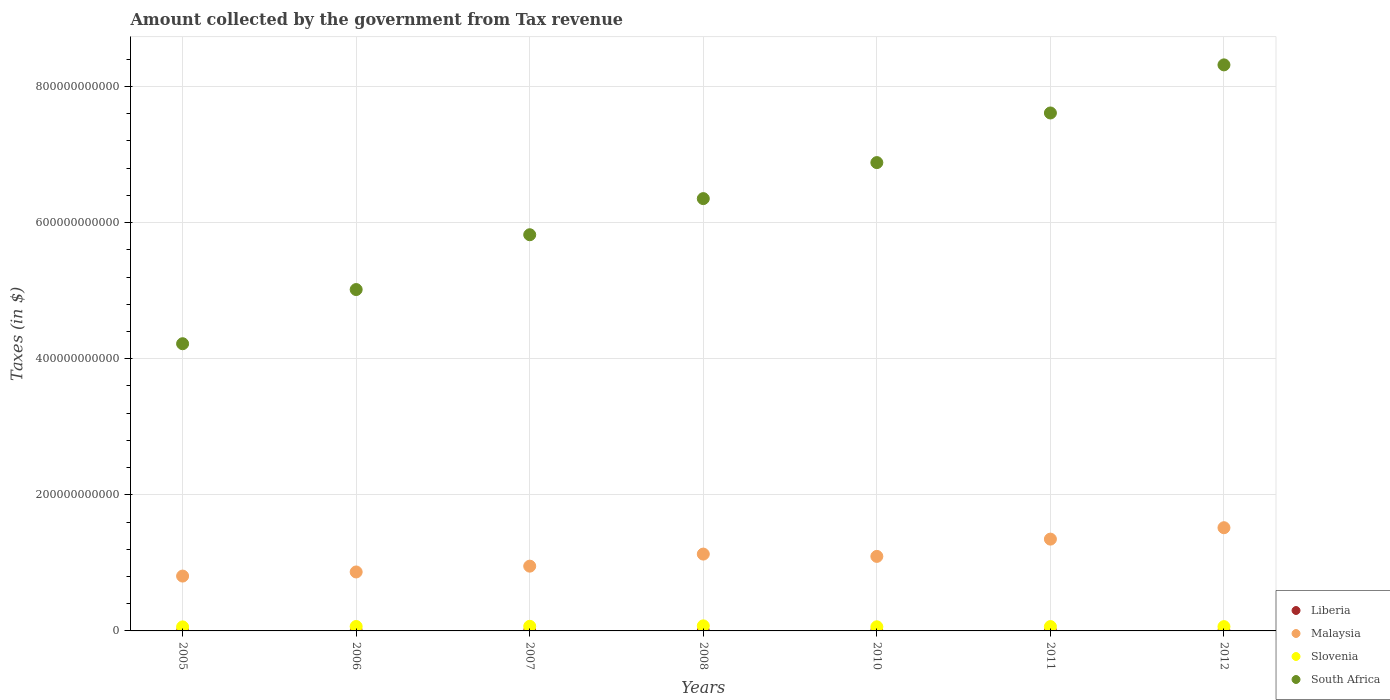How many different coloured dotlines are there?
Make the answer very short. 4. What is the amount collected by the government from tax revenue in Malaysia in 2010?
Give a very brief answer. 1.10e+11. Across all years, what is the maximum amount collected by the government from tax revenue in South Africa?
Make the answer very short. 8.32e+11. Across all years, what is the minimum amount collected by the government from tax revenue in South Africa?
Make the answer very short. 4.22e+11. What is the total amount collected by the government from tax revenue in South Africa in the graph?
Provide a short and direct response. 4.42e+12. What is the difference between the amount collected by the government from tax revenue in Liberia in 2010 and that in 2012?
Provide a short and direct response. -1.79e+06. What is the difference between the amount collected by the government from tax revenue in Slovenia in 2006 and the amount collected by the government from tax revenue in Liberia in 2008?
Your response must be concise. 6.52e+09. What is the average amount collected by the government from tax revenue in Malaysia per year?
Offer a very short reply. 1.10e+11. In the year 2011, what is the difference between the amount collected by the government from tax revenue in Slovenia and amount collected by the government from tax revenue in Malaysia?
Offer a very short reply. -1.28e+11. In how many years, is the amount collected by the government from tax revenue in Malaysia greater than 40000000000 $?
Your response must be concise. 7. What is the ratio of the amount collected by the government from tax revenue in Liberia in 2006 to that in 2011?
Provide a short and direct response. 0.38. Is the difference between the amount collected by the government from tax revenue in Slovenia in 2007 and 2012 greater than the difference between the amount collected by the government from tax revenue in Malaysia in 2007 and 2012?
Offer a very short reply. Yes. What is the difference between the highest and the second highest amount collected by the government from tax revenue in South Africa?
Ensure brevity in your answer.  7.07e+1. What is the difference between the highest and the lowest amount collected by the government from tax revenue in South Africa?
Offer a very short reply. 4.10e+11. In how many years, is the amount collected by the government from tax revenue in Malaysia greater than the average amount collected by the government from tax revenue in Malaysia taken over all years?
Offer a very short reply. 3. Is it the case that in every year, the sum of the amount collected by the government from tax revenue in Slovenia and amount collected by the government from tax revenue in Liberia  is greater than the sum of amount collected by the government from tax revenue in South Africa and amount collected by the government from tax revenue in Malaysia?
Ensure brevity in your answer.  No. Is it the case that in every year, the sum of the amount collected by the government from tax revenue in Slovenia and amount collected by the government from tax revenue in Liberia  is greater than the amount collected by the government from tax revenue in Malaysia?
Offer a very short reply. No. Does the amount collected by the government from tax revenue in Malaysia monotonically increase over the years?
Your answer should be very brief. No. Is the amount collected by the government from tax revenue in Malaysia strictly greater than the amount collected by the government from tax revenue in South Africa over the years?
Your answer should be compact. No. Is the amount collected by the government from tax revenue in Slovenia strictly less than the amount collected by the government from tax revenue in Malaysia over the years?
Your response must be concise. Yes. How many dotlines are there?
Offer a terse response. 4. How many years are there in the graph?
Keep it short and to the point. 7. What is the difference between two consecutive major ticks on the Y-axis?
Your answer should be very brief. 2.00e+11. Are the values on the major ticks of Y-axis written in scientific E-notation?
Your answer should be very brief. No. Does the graph contain grids?
Keep it short and to the point. Yes. How are the legend labels stacked?
Your response must be concise. Vertical. What is the title of the graph?
Give a very brief answer. Amount collected by the government from Tax revenue. Does "Seychelles" appear as one of the legend labels in the graph?
Keep it short and to the point. No. What is the label or title of the X-axis?
Provide a short and direct response. Years. What is the label or title of the Y-axis?
Make the answer very short. Taxes (in $). What is the Taxes (in $) in Liberia in 2005?
Provide a succinct answer. 1.27e+06. What is the Taxes (in $) of Malaysia in 2005?
Your response must be concise. 8.06e+1. What is the Taxes (in $) of Slovenia in 2005?
Offer a very short reply. 5.90e+09. What is the Taxes (in $) in South Africa in 2005?
Keep it short and to the point. 4.22e+11. What is the Taxes (in $) of Liberia in 2006?
Your response must be concise. 1.40e+06. What is the Taxes (in $) of Malaysia in 2006?
Your response must be concise. 8.66e+1. What is the Taxes (in $) in Slovenia in 2006?
Offer a terse response. 6.52e+09. What is the Taxes (in $) in South Africa in 2006?
Ensure brevity in your answer.  5.02e+11. What is the Taxes (in $) of Liberia in 2007?
Your answer should be compact. 2.29e+06. What is the Taxes (in $) of Malaysia in 2007?
Your answer should be compact. 9.52e+1. What is the Taxes (in $) of Slovenia in 2007?
Give a very brief answer. 6.79e+09. What is the Taxes (in $) of South Africa in 2007?
Make the answer very short. 5.82e+11. What is the Taxes (in $) in Liberia in 2008?
Your answer should be very brief. 2.69e+06. What is the Taxes (in $) of Malaysia in 2008?
Provide a succinct answer. 1.13e+11. What is the Taxes (in $) in Slovenia in 2008?
Offer a very short reply. 7.43e+09. What is the Taxes (in $) of South Africa in 2008?
Offer a very short reply. 6.35e+11. What is the Taxes (in $) in Liberia in 2010?
Keep it short and to the point. 3.14e+06. What is the Taxes (in $) of Malaysia in 2010?
Offer a very short reply. 1.10e+11. What is the Taxes (in $) in Slovenia in 2010?
Provide a succinct answer. 6.07e+09. What is the Taxes (in $) in South Africa in 2010?
Provide a succinct answer. 6.88e+11. What is the Taxes (in $) in Liberia in 2011?
Your response must be concise. 3.70e+06. What is the Taxes (in $) of Malaysia in 2011?
Your answer should be very brief. 1.35e+11. What is the Taxes (in $) in Slovenia in 2011?
Give a very brief answer. 6.39e+09. What is the Taxes (in $) in South Africa in 2011?
Offer a very short reply. 7.61e+11. What is the Taxes (in $) in Liberia in 2012?
Your answer should be compact. 4.93e+06. What is the Taxes (in $) of Malaysia in 2012?
Ensure brevity in your answer.  1.52e+11. What is the Taxes (in $) of Slovenia in 2012?
Make the answer very short. 6.32e+09. What is the Taxes (in $) of South Africa in 2012?
Your answer should be compact. 8.32e+11. Across all years, what is the maximum Taxes (in $) of Liberia?
Provide a short and direct response. 4.93e+06. Across all years, what is the maximum Taxes (in $) of Malaysia?
Give a very brief answer. 1.52e+11. Across all years, what is the maximum Taxes (in $) of Slovenia?
Offer a very short reply. 7.43e+09. Across all years, what is the maximum Taxes (in $) in South Africa?
Make the answer very short. 8.32e+11. Across all years, what is the minimum Taxes (in $) of Liberia?
Keep it short and to the point. 1.27e+06. Across all years, what is the minimum Taxes (in $) in Malaysia?
Your response must be concise. 8.06e+1. Across all years, what is the minimum Taxes (in $) of Slovenia?
Make the answer very short. 5.90e+09. Across all years, what is the minimum Taxes (in $) of South Africa?
Offer a terse response. 4.22e+11. What is the total Taxes (in $) in Liberia in the graph?
Your answer should be very brief. 1.94e+07. What is the total Taxes (in $) of Malaysia in the graph?
Keep it short and to the point. 7.71e+11. What is the total Taxes (in $) in Slovenia in the graph?
Ensure brevity in your answer.  4.54e+1. What is the total Taxes (in $) in South Africa in the graph?
Your answer should be compact. 4.42e+12. What is the difference between the Taxes (in $) in Liberia in 2005 and that in 2006?
Your answer should be very brief. -1.25e+05. What is the difference between the Taxes (in $) in Malaysia in 2005 and that in 2006?
Your answer should be very brief. -6.04e+09. What is the difference between the Taxes (in $) in Slovenia in 2005 and that in 2006?
Make the answer very short. -6.18e+08. What is the difference between the Taxes (in $) in South Africa in 2005 and that in 2006?
Offer a very short reply. -7.96e+1. What is the difference between the Taxes (in $) in Liberia in 2005 and that in 2007?
Offer a terse response. -1.02e+06. What is the difference between the Taxes (in $) of Malaysia in 2005 and that in 2007?
Ensure brevity in your answer.  -1.46e+1. What is the difference between the Taxes (in $) of Slovenia in 2005 and that in 2007?
Provide a succinct answer. -8.91e+08. What is the difference between the Taxes (in $) in South Africa in 2005 and that in 2007?
Your answer should be compact. -1.60e+11. What is the difference between the Taxes (in $) in Liberia in 2005 and that in 2008?
Offer a very short reply. -1.42e+06. What is the difference between the Taxes (in $) of Malaysia in 2005 and that in 2008?
Make the answer very short. -3.23e+1. What is the difference between the Taxes (in $) in Slovenia in 2005 and that in 2008?
Your answer should be compact. -1.53e+09. What is the difference between the Taxes (in $) of South Africa in 2005 and that in 2008?
Your answer should be compact. -2.13e+11. What is the difference between the Taxes (in $) of Liberia in 2005 and that in 2010?
Ensure brevity in your answer.  -1.87e+06. What is the difference between the Taxes (in $) of Malaysia in 2005 and that in 2010?
Offer a terse response. -2.89e+1. What is the difference between the Taxes (in $) in Slovenia in 2005 and that in 2010?
Your answer should be compact. -1.66e+08. What is the difference between the Taxes (in $) of South Africa in 2005 and that in 2010?
Provide a short and direct response. -2.66e+11. What is the difference between the Taxes (in $) in Liberia in 2005 and that in 2011?
Ensure brevity in your answer.  -2.43e+06. What is the difference between the Taxes (in $) of Malaysia in 2005 and that in 2011?
Offer a very short reply. -5.43e+1. What is the difference between the Taxes (in $) in Slovenia in 2005 and that in 2011?
Keep it short and to the point. -4.91e+08. What is the difference between the Taxes (in $) in South Africa in 2005 and that in 2011?
Provide a succinct answer. -3.39e+11. What is the difference between the Taxes (in $) in Liberia in 2005 and that in 2012?
Ensure brevity in your answer.  -3.66e+06. What is the difference between the Taxes (in $) in Malaysia in 2005 and that in 2012?
Make the answer very short. -7.10e+1. What is the difference between the Taxes (in $) of Slovenia in 2005 and that in 2012?
Keep it short and to the point. -4.16e+08. What is the difference between the Taxes (in $) of South Africa in 2005 and that in 2012?
Your answer should be very brief. -4.10e+11. What is the difference between the Taxes (in $) in Liberia in 2006 and that in 2007?
Offer a terse response. -8.90e+05. What is the difference between the Taxes (in $) in Malaysia in 2006 and that in 2007?
Ensure brevity in your answer.  -8.54e+09. What is the difference between the Taxes (in $) in Slovenia in 2006 and that in 2007?
Your answer should be very brief. -2.73e+08. What is the difference between the Taxes (in $) in South Africa in 2006 and that in 2007?
Your answer should be very brief. -8.05e+1. What is the difference between the Taxes (in $) in Liberia in 2006 and that in 2008?
Keep it short and to the point. -1.29e+06. What is the difference between the Taxes (in $) of Malaysia in 2006 and that in 2008?
Offer a terse response. -2.63e+1. What is the difference between the Taxes (in $) in Slovenia in 2006 and that in 2008?
Ensure brevity in your answer.  -9.12e+08. What is the difference between the Taxes (in $) of South Africa in 2006 and that in 2008?
Offer a very short reply. -1.34e+11. What is the difference between the Taxes (in $) in Liberia in 2006 and that in 2010?
Ensure brevity in your answer.  -1.74e+06. What is the difference between the Taxes (in $) of Malaysia in 2006 and that in 2010?
Provide a succinct answer. -2.29e+1. What is the difference between the Taxes (in $) in Slovenia in 2006 and that in 2010?
Keep it short and to the point. 4.52e+08. What is the difference between the Taxes (in $) in South Africa in 2006 and that in 2010?
Your response must be concise. -1.87e+11. What is the difference between the Taxes (in $) in Liberia in 2006 and that in 2011?
Your answer should be compact. -2.31e+06. What is the difference between the Taxes (in $) of Malaysia in 2006 and that in 2011?
Make the answer very short. -4.83e+1. What is the difference between the Taxes (in $) in Slovenia in 2006 and that in 2011?
Make the answer very short. 1.27e+08. What is the difference between the Taxes (in $) in South Africa in 2006 and that in 2011?
Your response must be concise. -2.59e+11. What is the difference between the Taxes (in $) in Liberia in 2006 and that in 2012?
Your response must be concise. -3.53e+06. What is the difference between the Taxes (in $) of Malaysia in 2006 and that in 2012?
Offer a terse response. -6.50e+1. What is the difference between the Taxes (in $) of Slovenia in 2006 and that in 2012?
Your response must be concise. 2.02e+08. What is the difference between the Taxes (in $) of South Africa in 2006 and that in 2012?
Provide a succinct answer. -3.30e+11. What is the difference between the Taxes (in $) in Liberia in 2007 and that in 2008?
Provide a short and direct response. -4.02e+05. What is the difference between the Taxes (in $) in Malaysia in 2007 and that in 2008?
Ensure brevity in your answer.  -1.77e+1. What is the difference between the Taxes (in $) of Slovenia in 2007 and that in 2008?
Keep it short and to the point. -6.39e+08. What is the difference between the Taxes (in $) of South Africa in 2007 and that in 2008?
Your answer should be compact. -5.31e+1. What is the difference between the Taxes (in $) of Liberia in 2007 and that in 2010?
Ensure brevity in your answer.  -8.50e+05. What is the difference between the Taxes (in $) of Malaysia in 2007 and that in 2010?
Offer a very short reply. -1.43e+1. What is the difference between the Taxes (in $) in Slovenia in 2007 and that in 2010?
Keep it short and to the point. 7.25e+08. What is the difference between the Taxes (in $) in South Africa in 2007 and that in 2010?
Give a very brief answer. -1.06e+11. What is the difference between the Taxes (in $) of Liberia in 2007 and that in 2011?
Offer a very short reply. -1.42e+06. What is the difference between the Taxes (in $) of Malaysia in 2007 and that in 2011?
Give a very brief answer. -3.97e+1. What is the difference between the Taxes (in $) in Slovenia in 2007 and that in 2011?
Make the answer very short. 4.00e+08. What is the difference between the Taxes (in $) of South Africa in 2007 and that in 2011?
Make the answer very short. -1.79e+11. What is the difference between the Taxes (in $) in Liberia in 2007 and that in 2012?
Provide a short and direct response. -2.64e+06. What is the difference between the Taxes (in $) of Malaysia in 2007 and that in 2012?
Make the answer very short. -5.65e+1. What is the difference between the Taxes (in $) in Slovenia in 2007 and that in 2012?
Your answer should be very brief. 4.75e+08. What is the difference between the Taxes (in $) of South Africa in 2007 and that in 2012?
Your answer should be compact. -2.50e+11. What is the difference between the Taxes (in $) of Liberia in 2008 and that in 2010?
Offer a terse response. -4.48e+05. What is the difference between the Taxes (in $) of Malaysia in 2008 and that in 2010?
Make the answer very short. 3.38e+09. What is the difference between the Taxes (in $) in Slovenia in 2008 and that in 2010?
Provide a succinct answer. 1.36e+09. What is the difference between the Taxes (in $) in South Africa in 2008 and that in 2010?
Your answer should be compact. -5.29e+1. What is the difference between the Taxes (in $) of Liberia in 2008 and that in 2011?
Offer a terse response. -1.01e+06. What is the difference between the Taxes (in $) in Malaysia in 2008 and that in 2011?
Give a very brief answer. -2.20e+1. What is the difference between the Taxes (in $) of Slovenia in 2008 and that in 2011?
Your response must be concise. 1.04e+09. What is the difference between the Taxes (in $) of South Africa in 2008 and that in 2011?
Your answer should be very brief. -1.26e+11. What is the difference between the Taxes (in $) of Liberia in 2008 and that in 2012?
Your answer should be very brief. -2.24e+06. What is the difference between the Taxes (in $) in Malaysia in 2008 and that in 2012?
Your answer should be very brief. -3.87e+1. What is the difference between the Taxes (in $) of Slovenia in 2008 and that in 2012?
Ensure brevity in your answer.  1.11e+09. What is the difference between the Taxes (in $) of South Africa in 2008 and that in 2012?
Offer a very short reply. -1.97e+11. What is the difference between the Taxes (in $) of Liberia in 2010 and that in 2011?
Provide a succinct answer. -5.66e+05. What is the difference between the Taxes (in $) in Malaysia in 2010 and that in 2011?
Provide a short and direct response. -2.54e+1. What is the difference between the Taxes (in $) of Slovenia in 2010 and that in 2011?
Make the answer very short. -3.25e+08. What is the difference between the Taxes (in $) of South Africa in 2010 and that in 2011?
Make the answer very short. -7.29e+1. What is the difference between the Taxes (in $) of Liberia in 2010 and that in 2012?
Provide a short and direct response. -1.79e+06. What is the difference between the Taxes (in $) in Malaysia in 2010 and that in 2012?
Offer a very short reply. -4.21e+1. What is the difference between the Taxes (in $) of Slovenia in 2010 and that in 2012?
Provide a succinct answer. -2.50e+08. What is the difference between the Taxes (in $) in South Africa in 2010 and that in 2012?
Offer a terse response. -1.44e+11. What is the difference between the Taxes (in $) in Liberia in 2011 and that in 2012?
Offer a very short reply. -1.22e+06. What is the difference between the Taxes (in $) of Malaysia in 2011 and that in 2012?
Your response must be concise. -1.68e+1. What is the difference between the Taxes (in $) in Slovenia in 2011 and that in 2012?
Your answer should be compact. 7.47e+07. What is the difference between the Taxes (in $) in South Africa in 2011 and that in 2012?
Give a very brief answer. -7.07e+1. What is the difference between the Taxes (in $) in Liberia in 2005 and the Taxes (in $) in Malaysia in 2006?
Provide a succinct answer. -8.66e+1. What is the difference between the Taxes (in $) of Liberia in 2005 and the Taxes (in $) of Slovenia in 2006?
Provide a succinct answer. -6.52e+09. What is the difference between the Taxes (in $) of Liberia in 2005 and the Taxes (in $) of South Africa in 2006?
Provide a short and direct response. -5.02e+11. What is the difference between the Taxes (in $) of Malaysia in 2005 and the Taxes (in $) of Slovenia in 2006?
Offer a terse response. 7.41e+1. What is the difference between the Taxes (in $) of Malaysia in 2005 and the Taxes (in $) of South Africa in 2006?
Make the answer very short. -4.21e+11. What is the difference between the Taxes (in $) in Slovenia in 2005 and the Taxes (in $) in South Africa in 2006?
Ensure brevity in your answer.  -4.96e+11. What is the difference between the Taxes (in $) in Liberia in 2005 and the Taxes (in $) in Malaysia in 2007?
Your answer should be very brief. -9.52e+1. What is the difference between the Taxes (in $) in Liberia in 2005 and the Taxes (in $) in Slovenia in 2007?
Provide a short and direct response. -6.79e+09. What is the difference between the Taxes (in $) in Liberia in 2005 and the Taxes (in $) in South Africa in 2007?
Your answer should be very brief. -5.82e+11. What is the difference between the Taxes (in $) in Malaysia in 2005 and the Taxes (in $) in Slovenia in 2007?
Offer a terse response. 7.38e+1. What is the difference between the Taxes (in $) in Malaysia in 2005 and the Taxes (in $) in South Africa in 2007?
Keep it short and to the point. -5.02e+11. What is the difference between the Taxes (in $) in Slovenia in 2005 and the Taxes (in $) in South Africa in 2007?
Offer a very short reply. -5.76e+11. What is the difference between the Taxes (in $) in Liberia in 2005 and the Taxes (in $) in Malaysia in 2008?
Make the answer very short. -1.13e+11. What is the difference between the Taxes (in $) in Liberia in 2005 and the Taxes (in $) in Slovenia in 2008?
Provide a short and direct response. -7.43e+09. What is the difference between the Taxes (in $) in Liberia in 2005 and the Taxes (in $) in South Africa in 2008?
Ensure brevity in your answer.  -6.35e+11. What is the difference between the Taxes (in $) of Malaysia in 2005 and the Taxes (in $) of Slovenia in 2008?
Provide a succinct answer. 7.32e+1. What is the difference between the Taxes (in $) in Malaysia in 2005 and the Taxes (in $) in South Africa in 2008?
Your answer should be compact. -5.55e+11. What is the difference between the Taxes (in $) in Slovenia in 2005 and the Taxes (in $) in South Africa in 2008?
Your answer should be compact. -6.29e+11. What is the difference between the Taxes (in $) of Liberia in 2005 and the Taxes (in $) of Malaysia in 2010?
Provide a short and direct response. -1.10e+11. What is the difference between the Taxes (in $) of Liberia in 2005 and the Taxes (in $) of Slovenia in 2010?
Make the answer very short. -6.06e+09. What is the difference between the Taxes (in $) of Liberia in 2005 and the Taxes (in $) of South Africa in 2010?
Provide a succinct answer. -6.88e+11. What is the difference between the Taxes (in $) of Malaysia in 2005 and the Taxes (in $) of Slovenia in 2010?
Your answer should be compact. 7.45e+1. What is the difference between the Taxes (in $) of Malaysia in 2005 and the Taxes (in $) of South Africa in 2010?
Provide a short and direct response. -6.08e+11. What is the difference between the Taxes (in $) in Slovenia in 2005 and the Taxes (in $) in South Africa in 2010?
Your answer should be compact. -6.82e+11. What is the difference between the Taxes (in $) of Liberia in 2005 and the Taxes (in $) of Malaysia in 2011?
Offer a terse response. -1.35e+11. What is the difference between the Taxes (in $) of Liberia in 2005 and the Taxes (in $) of Slovenia in 2011?
Your response must be concise. -6.39e+09. What is the difference between the Taxes (in $) of Liberia in 2005 and the Taxes (in $) of South Africa in 2011?
Your answer should be very brief. -7.61e+11. What is the difference between the Taxes (in $) of Malaysia in 2005 and the Taxes (in $) of Slovenia in 2011?
Give a very brief answer. 7.42e+1. What is the difference between the Taxes (in $) of Malaysia in 2005 and the Taxes (in $) of South Africa in 2011?
Give a very brief answer. -6.80e+11. What is the difference between the Taxes (in $) in Slovenia in 2005 and the Taxes (in $) in South Africa in 2011?
Your answer should be very brief. -7.55e+11. What is the difference between the Taxes (in $) of Liberia in 2005 and the Taxes (in $) of Malaysia in 2012?
Ensure brevity in your answer.  -1.52e+11. What is the difference between the Taxes (in $) of Liberia in 2005 and the Taxes (in $) of Slovenia in 2012?
Keep it short and to the point. -6.31e+09. What is the difference between the Taxes (in $) in Liberia in 2005 and the Taxes (in $) in South Africa in 2012?
Give a very brief answer. -8.32e+11. What is the difference between the Taxes (in $) of Malaysia in 2005 and the Taxes (in $) of Slovenia in 2012?
Your answer should be compact. 7.43e+1. What is the difference between the Taxes (in $) of Malaysia in 2005 and the Taxes (in $) of South Africa in 2012?
Give a very brief answer. -7.51e+11. What is the difference between the Taxes (in $) of Slovenia in 2005 and the Taxes (in $) of South Africa in 2012?
Offer a terse response. -8.26e+11. What is the difference between the Taxes (in $) in Liberia in 2006 and the Taxes (in $) in Malaysia in 2007?
Your answer should be compact. -9.52e+1. What is the difference between the Taxes (in $) in Liberia in 2006 and the Taxes (in $) in Slovenia in 2007?
Keep it short and to the point. -6.79e+09. What is the difference between the Taxes (in $) in Liberia in 2006 and the Taxes (in $) in South Africa in 2007?
Offer a very short reply. -5.82e+11. What is the difference between the Taxes (in $) of Malaysia in 2006 and the Taxes (in $) of Slovenia in 2007?
Offer a very short reply. 7.98e+1. What is the difference between the Taxes (in $) of Malaysia in 2006 and the Taxes (in $) of South Africa in 2007?
Offer a terse response. -4.96e+11. What is the difference between the Taxes (in $) of Slovenia in 2006 and the Taxes (in $) of South Africa in 2007?
Your response must be concise. -5.76e+11. What is the difference between the Taxes (in $) in Liberia in 2006 and the Taxes (in $) in Malaysia in 2008?
Offer a terse response. -1.13e+11. What is the difference between the Taxes (in $) of Liberia in 2006 and the Taxes (in $) of Slovenia in 2008?
Ensure brevity in your answer.  -7.43e+09. What is the difference between the Taxes (in $) in Liberia in 2006 and the Taxes (in $) in South Africa in 2008?
Keep it short and to the point. -6.35e+11. What is the difference between the Taxes (in $) of Malaysia in 2006 and the Taxes (in $) of Slovenia in 2008?
Keep it short and to the point. 7.92e+1. What is the difference between the Taxes (in $) in Malaysia in 2006 and the Taxes (in $) in South Africa in 2008?
Provide a short and direct response. -5.49e+11. What is the difference between the Taxes (in $) of Slovenia in 2006 and the Taxes (in $) of South Africa in 2008?
Your response must be concise. -6.29e+11. What is the difference between the Taxes (in $) in Liberia in 2006 and the Taxes (in $) in Malaysia in 2010?
Your response must be concise. -1.10e+11. What is the difference between the Taxes (in $) of Liberia in 2006 and the Taxes (in $) of Slovenia in 2010?
Make the answer very short. -6.06e+09. What is the difference between the Taxes (in $) in Liberia in 2006 and the Taxes (in $) in South Africa in 2010?
Provide a succinct answer. -6.88e+11. What is the difference between the Taxes (in $) of Malaysia in 2006 and the Taxes (in $) of Slovenia in 2010?
Ensure brevity in your answer.  8.06e+1. What is the difference between the Taxes (in $) in Malaysia in 2006 and the Taxes (in $) in South Africa in 2010?
Give a very brief answer. -6.02e+11. What is the difference between the Taxes (in $) in Slovenia in 2006 and the Taxes (in $) in South Africa in 2010?
Make the answer very short. -6.82e+11. What is the difference between the Taxes (in $) of Liberia in 2006 and the Taxes (in $) of Malaysia in 2011?
Provide a succinct answer. -1.35e+11. What is the difference between the Taxes (in $) in Liberia in 2006 and the Taxes (in $) in Slovenia in 2011?
Make the answer very short. -6.39e+09. What is the difference between the Taxes (in $) of Liberia in 2006 and the Taxes (in $) of South Africa in 2011?
Keep it short and to the point. -7.61e+11. What is the difference between the Taxes (in $) of Malaysia in 2006 and the Taxes (in $) of Slovenia in 2011?
Provide a succinct answer. 8.02e+1. What is the difference between the Taxes (in $) in Malaysia in 2006 and the Taxes (in $) in South Africa in 2011?
Your answer should be very brief. -6.74e+11. What is the difference between the Taxes (in $) of Slovenia in 2006 and the Taxes (in $) of South Africa in 2011?
Provide a short and direct response. -7.55e+11. What is the difference between the Taxes (in $) in Liberia in 2006 and the Taxes (in $) in Malaysia in 2012?
Your answer should be very brief. -1.52e+11. What is the difference between the Taxes (in $) in Liberia in 2006 and the Taxes (in $) in Slovenia in 2012?
Provide a short and direct response. -6.31e+09. What is the difference between the Taxes (in $) of Liberia in 2006 and the Taxes (in $) of South Africa in 2012?
Provide a short and direct response. -8.32e+11. What is the difference between the Taxes (in $) in Malaysia in 2006 and the Taxes (in $) in Slovenia in 2012?
Keep it short and to the point. 8.03e+1. What is the difference between the Taxes (in $) in Malaysia in 2006 and the Taxes (in $) in South Africa in 2012?
Offer a very short reply. -7.45e+11. What is the difference between the Taxes (in $) in Slovenia in 2006 and the Taxes (in $) in South Africa in 2012?
Your answer should be compact. -8.25e+11. What is the difference between the Taxes (in $) in Liberia in 2007 and the Taxes (in $) in Malaysia in 2008?
Give a very brief answer. -1.13e+11. What is the difference between the Taxes (in $) of Liberia in 2007 and the Taxes (in $) of Slovenia in 2008?
Give a very brief answer. -7.43e+09. What is the difference between the Taxes (in $) in Liberia in 2007 and the Taxes (in $) in South Africa in 2008?
Your response must be concise. -6.35e+11. What is the difference between the Taxes (in $) in Malaysia in 2007 and the Taxes (in $) in Slovenia in 2008?
Your response must be concise. 8.77e+1. What is the difference between the Taxes (in $) in Malaysia in 2007 and the Taxes (in $) in South Africa in 2008?
Make the answer very short. -5.40e+11. What is the difference between the Taxes (in $) in Slovenia in 2007 and the Taxes (in $) in South Africa in 2008?
Provide a short and direct response. -6.28e+11. What is the difference between the Taxes (in $) in Liberia in 2007 and the Taxes (in $) in Malaysia in 2010?
Provide a short and direct response. -1.10e+11. What is the difference between the Taxes (in $) in Liberia in 2007 and the Taxes (in $) in Slovenia in 2010?
Offer a terse response. -6.06e+09. What is the difference between the Taxes (in $) of Liberia in 2007 and the Taxes (in $) of South Africa in 2010?
Ensure brevity in your answer.  -6.88e+11. What is the difference between the Taxes (in $) in Malaysia in 2007 and the Taxes (in $) in Slovenia in 2010?
Your response must be concise. 8.91e+1. What is the difference between the Taxes (in $) in Malaysia in 2007 and the Taxes (in $) in South Africa in 2010?
Ensure brevity in your answer.  -5.93e+11. What is the difference between the Taxes (in $) in Slovenia in 2007 and the Taxes (in $) in South Africa in 2010?
Your response must be concise. -6.81e+11. What is the difference between the Taxes (in $) of Liberia in 2007 and the Taxes (in $) of Malaysia in 2011?
Offer a terse response. -1.35e+11. What is the difference between the Taxes (in $) in Liberia in 2007 and the Taxes (in $) in Slovenia in 2011?
Provide a short and direct response. -6.39e+09. What is the difference between the Taxes (in $) of Liberia in 2007 and the Taxes (in $) of South Africa in 2011?
Your response must be concise. -7.61e+11. What is the difference between the Taxes (in $) in Malaysia in 2007 and the Taxes (in $) in Slovenia in 2011?
Provide a short and direct response. 8.88e+1. What is the difference between the Taxes (in $) in Malaysia in 2007 and the Taxes (in $) in South Africa in 2011?
Your answer should be very brief. -6.66e+11. What is the difference between the Taxes (in $) in Slovenia in 2007 and the Taxes (in $) in South Africa in 2011?
Provide a short and direct response. -7.54e+11. What is the difference between the Taxes (in $) of Liberia in 2007 and the Taxes (in $) of Malaysia in 2012?
Ensure brevity in your answer.  -1.52e+11. What is the difference between the Taxes (in $) in Liberia in 2007 and the Taxes (in $) in Slovenia in 2012?
Offer a terse response. -6.31e+09. What is the difference between the Taxes (in $) of Liberia in 2007 and the Taxes (in $) of South Africa in 2012?
Your answer should be very brief. -8.32e+11. What is the difference between the Taxes (in $) in Malaysia in 2007 and the Taxes (in $) in Slovenia in 2012?
Keep it short and to the point. 8.89e+1. What is the difference between the Taxes (in $) in Malaysia in 2007 and the Taxes (in $) in South Africa in 2012?
Give a very brief answer. -7.37e+11. What is the difference between the Taxes (in $) of Slovenia in 2007 and the Taxes (in $) of South Africa in 2012?
Keep it short and to the point. -8.25e+11. What is the difference between the Taxes (in $) in Liberia in 2008 and the Taxes (in $) in Malaysia in 2010?
Give a very brief answer. -1.10e+11. What is the difference between the Taxes (in $) in Liberia in 2008 and the Taxes (in $) in Slovenia in 2010?
Provide a short and direct response. -6.06e+09. What is the difference between the Taxes (in $) in Liberia in 2008 and the Taxes (in $) in South Africa in 2010?
Offer a terse response. -6.88e+11. What is the difference between the Taxes (in $) in Malaysia in 2008 and the Taxes (in $) in Slovenia in 2010?
Offer a terse response. 1.07e+11. What is the difference between the Taxes (in $) of Malaysia in 2008 and the Taxes (in $) of South Africa in 2010?
Make the answer very short. -5.75e+11. What is the difference between the Taxes (in $) in Slovenia in 2008 and the Taxes (in $) in South Africa in 2010?
Ensure brevity in your answer.  -6.81e+11. What is the difference between the Taxes (in $) of Liberia in 2008 and the Taxes (in $) of Malaysia in 2011?
Offer a very short reply. -1.35e+11. What is the difference between the Taxes (in $) of Liberia in 2008 and the Taxes (in $) of Slovenia in 2011?
Ensure brevity in your answer.  -6.39e+09. What is the difference between the Taxes (in $) in Liberia in 2008 and the Taxes (in $) in South Africa in 2011?
Offer a very short reply. -7.61e+11. What is the difference between the Taxes (in $) of Malaysia in 2008 and the Taxes (in $) of Slovenia in 2011?
Keep it short and to the point. 1.07e+11. What is the difference between the Taxes (in $) in Malaysia in 2008 and the Taxes (in $) in South Africa in 2011?
Your answer should be compact. -6.48e+11. What is the difference between the Taxes (in $) in Slovenia in 2008 and the Taxes (in $) in South Africa in 2011?
Your response must be concise. -7.54e+11. What is the difference between the Taxes (in $) in Liberia in 2008 and the Taxes (in $) in Malaysia in 2012?
Offer a very short reply. -1.52e+11. What is the difference between the Taxes (in $) in Liberia in 2008 and the Taxes (in $) in Slovenia in 2012?
Make the answer very short. -6.31e+09. What is the difference between the Taxes (in $) in Liberia in 2008 and the Taxes (in $) in South Africa in 2012?
Offer a very short reply. -8.32e+11. What is the difference between the Taxes (in $) of Malaysia in 2008 and the Taxes (in $) of Slovenia in 2012?
Offer a very short reply. 1.07e+11. What is the difference between the Taxes (in $) in Malaysia in 2008 and the Taxes (in $) in South Africa in 2012?
Make the answer very short. -7.19e+11. What is the difference between the Taxes (in $) of Slovenia in 2008 and the Taxes (in $) of South Africa in 2012?
Your response must be concise. -8.24e+11. What is the difference between the Taxes (in $) in Liberia in 2010 and the Taxes (in $) in Malaysia in 2011?
Keep it short and to the point. -1.35e+11. What is the difference between the Taxes (in $) of Liberia in 2010 and the Taxes (in $) of Slovenia in 2011?
Provide a short and direct response. -6.39e+09. What is the difference between the Taxes (in $) of Liberia in 2010 and the Taxes (in $) of South Africa in 2011?
Your response must be concise. -7.61e+11. What is the difference between the Taxes (in $) in Malaysia in 2010 and the Taxes (in $) in Slovenia in 2011?
Offer a terse response. 1.03e+11. What is the difference between the Taxes (in $) of Malaysia in 2010 and the Taxes (in $) of South Africa in 2011?
Provide a short and direct response. -6.52e+11. What is the difference between the Taxes (in $) of Slovenia in 2010 and the Taxes (in $) of South Africa in 2011?
Your response must be concise. -7.55e+11. What is the difference between the Taxes (in $) of Liberia in 2010 and the Taxes (in $) of Malaysia in 2012?
Provide a succinct answer. -1.52e+11. What is the difference between the Taxes (in $) in Liberia in 2010 and the Taxes (in $) in Slovenia in 2012?
Your answer should be very brief. -6.31e+09. What is the difference between the Taxes (in $) in Liberia in 2010 and the Taxes (in $) in South Africa in 2012?
Ensure brevity in your answer.  -8.32e+11. What is the difference between the Taxes (in $) of Malaysia in 2010 and the Taxes (in $) of Slovenia in 2012?
Ensure brevity in your answer.  1.03e+11. What is the difference between the Taxes (in $) of Malaysia in 2010 and the Taxes (in $) of South Africa in 2012?
Make the answer very short. -7.22e+11. What is the difference between the Taxes (in $) in Slovenia in 2010 and the Taxes (in $) in South Africa in 2012?
Give a very brief answer. -8.26e+11. What is the difference between the Taxes (in $) in Liberia in 2011 and the Taxes (in $) in Malaysia in 2012?
Your answer should be compact. -1.52e+11. What is the difference between the Taxes (in $) of Liberia in 2011 and the Taxes (in $) of Slovenia in 2012?
Provide a short and direct response. -6.31e+09. What is the difference between the Taxes (in $) in Liberia in 2011 and the Taxes (in $) in South Africa in 2012?
Offer a very short reply. -8.32e+11. What is the difference between the Taxes (in $) of Malaysia in 2011 and the Taxes (in $) of Slovenia in 2012?
Provide a short and direct response. 1.29e+11. What is the difference between the Taxes (in $) of Malaysia in 2011 and the Taxes (in $) of South Africa in 2012?
Your answer should be compact. -6.97e+11. What is the difference between the Taxes (in $) in Slovenia in 2011 and the Taxes (in $) in South Africa in 2012?
Give a very brief answer. -8.25e+11. What is the average Taxes (in $) in Liberia per year?
Provide a succinct answer. 2.77e+06. What is the average Taxes (in $) in Malaysia per year?
Provide a succinct answer. 1.10e+11. What is the average Taxes (in $) in Slovenia per year?
Offer a very short reply. 6.49e+09. What is the average Taxes (in $) in South Africa per year?
Provide a short and direct response. 6.32e+11. In the year 2005, what is the difference between the Taxes (in $) in Liberia and Taxes (in $) in Malaysia?
Offer a very short reply. -8.06e+1. In the year 2005, what is the difference between the Taxes (in $) of Liberia and Taxes (in $) of Slovenia?
Provide a succinct answer. -5.90e+09. In the year 2005, what is the difference between the Taxes (in $) of Liberia and Taxes (in $) of South Africa?
Offer a very short reply. -4.22e+11. In the year 2005, what is the difference between the Taxes (in $) of Malaysia and Taxes (in $) of Slovenia?
Provide a short and direct response. 7.47e+1. In the year 2005, what is the difference between the Taxes (in $) in Malaysia and Taxes (in $) in South Africa?
Provide a succinct answer. -3.41e+11. In the year 2005, what is the difference between the Taxes (in $) of Slovenia and Taxes (in $) of South Africa?
Your answer should be very brief. -4.16e+11. In the year 2006, what is the difference between the Taxes (in $) in Liberia and Taxes (in $) in Malaysia?
Offer a very short reply. -8.66e+1. In the year 2006, what is the difference between the Taxes (in $) in Liberia and Taxes (in $) in Slovenia?
Your answer should be compact. -6.52e+09. In the year 2006, what is the difference between the Taxes (in $) in Liberia and Taxes (in $) in South Africa?
Provide a short and direct response. -5.02e+11. In the year 2006, what is the difference between the Taxes (in $) of Malaysia and Taxes (in $) of Slovenia?
Keep it short and to the point. 8.01e+1. In the year 2006, what is the difference between the Taxes (in $) in Malaysia and Taxes (in $) in South Africa?
Give a very brief answer. -4.15e+11. In the year 2006, what is the difference between the Taxes (in $) of Slovenia and Taxes (in $) of South Africa?
Make the answer very short. -4.95e+11. In the year 2007, what is the difference between the Taxes (in $) in Liberia and Taxes (in $) in Malaysia?
Your answer should be very brief. -9.52e+1. In the year 2007, what is the difference between the Taxes (in $) of Liberia and Taxes (in $) of Slovenia?
Keep it short and to the point. -6.79e+09. In the year 2007, what is the difference between the Taxes (in $) in Liberia and Taxes (in $) in South Africa?
Keep it short and to the point. -5.82e+11. In the year 2007, what is the difference between the Taxes (in $) of Malaysia and Taxes (in $) of Slovenia?
Make the answer very short. 8.84e+1. In the year 2007, what is the difference between the Taxes (in $) of Malaysia and Taxes (in $) of South Africa?
Give a very brief answer. -4.87e+11. In the year 2007, what is the difference between the Taxes (in $) of Slovenia and Taxes (in $) of South Africa?
Your answer should be very brief. -5.75e+11. In the year 2008, what is the difference between the Taxes (in $) of Liberia and Taxes (in $) of Malaysia?
Your answer should be compact. -1.13e+11. In the year 2008, what is the difference between the Taxes (in $) of Liberia and Taxes (in $) of Slovenia?
Your answer should be compact. -7.43e+09. In the year 2008, what is the difference between the Taxes (in $) of Liberia and Taxes (in $) of South Africa?
Your answer should be compact. -6.35e+11. In the year 2008, what is the difference between the Taxes (in $) of Malaysia and Taxes (in $) of Slovenia?
Your answer should be compact. 1.05e+11. In the year 2008, what is the difference between the Taxes (in $) in Malaysia and Taxes (in $) in South Africa?
Keep it short and to the point. -5.22e+11. In the year 2008, what is the difference between the Taxes (in $) of Slovenia and Taxes (in $) of South Africa?
Offer a very short reply. -6.28e+11. In the year 2010, what is the difference between the Taxes (in $) of Liberia and Taxes (in $) of Malaysia?
Your response must be concise. -1.10e+11. In the year 2010, what is the difference between the Taxes (in $) in Liberia and Taxes (in $) in Slovenia?
Offer a terse response. -6.06e+09. In the year 2010, what is the difference between the Taxes (in $) in Liberia and Taxes (in $) in South Africa?
Provide a short and direct response. -6.88e+11. In the year 2010, what is the difference between the Taxes (in $) of Malaysia and Taxes (in $) of Slovenia?
Offer a very short reply. 1.03e+11. In the year 2010, what is the difference between the Taxes (in $) in Malaysia and Taxes (in $) in South Africa?
Your response must be concise. -5.79e+11. In the year 2010, what is the difference between the Taxes (in $) in Slovenia and Taxes (in $) in South Africa?
Make the answer very short. -6.82e+11. In the year 2011, what is the difference between the Taxes (in $) in Liberia and Taxes (in $) in Malaysia?
Your response must be concise. -1.35e+11. In the year 2011, what is the difference between the Taxes (in $) of Liberia and Taxes (in $) of Slovenia?
Provide a succinct answer. -6.39e+09. In the year 2011, what is the difference between the Taxes (in $) in Liberia and Taxes (in $) in South Africa?
Keep it short and to the point. -7.61e+11. In the year 2011, what is the difference between the Taxes (in $) of Malaysia and Taxes (in $) of Slovenia?
Offer a very short reply. 1.28e+11. In the year 2011, what is the difference between the Taxes (in $) of Malaysia and Taxes (in $) of South Africa?
Your response must be concise. -6.26e+11. In the year 2011, what is the difference between the Taxes (in $) in Slovenia and Taxes (in $) in South Africa?
Keep it short and to the point. -7.55e+11. In the year 2012, what is the difference between the Taxes (in $) of Liberia and Taxes (in $) of Malaysia?
Your answer should be very brief. -1.52e+11. In the year 2012, what is the difference between the Taxes (in $) in Liberia and Taxes (in $) in Slovenia?
Offer a very short reply. -6.31e+09. In the year 2012, what is the difference between the Taxes (in $) in Liberia and Taxes (in $) in South Africa?
Ensure brevity in your answer.  -8.32e+11. In the year 2012, what is the difference between the Taxes (in $) in Malaysia and Taxes (in $) in Slovenia?
Keep it short and to the point. 1.45e+11. In the year 2012, what is the difference between the Taxes (in $) of Malaysia and Taxes (in $) of South Africa?
Your response must be concise. -6.80e+11. In the year 2012, what is the difference between the Taxes (in $) of Slovenia and Taxes (in $) of South Africa?
Your response must be concise. -8.25e+11. What is the ratio of the Taxes (in $) of Liberia in 2005 to that in 2006?
Provide a short and direct response. 0.91. What is the ratio of the Taxes (in $) of Malaysia in 2005 to that in 2006?
Your answer should be compact. 0.93. What is the ratio of the Taxes (in $) of Slovenia in 2005 to that in 2006?
Offer a very short reply. 0.91. What is the ratio of the Taxes (in $) in South Africa in 2005 to that in 2006?
Provide a short and direct response. 0.84. What is the ratio of the Taxes (in $) in Liberia in 2005 to that in 2007?
Ensure brevity in your answer.  0.56. What is the ratio of the Taxes (in $) in Malaysia in 2005 to that in 2007?
Offer a terse response. 0.85. What is the ratio of the Taxes (in $) in Slovenia in 2005 to that in 2007?
Make the answer very short. 0.87. What is the ratio of the Taxes (in $) in South Africa in 2005 to that in 2007?
Offer a very short reply. 0.72. What is the ratio of the Taxes (in $) of Liberia in 2005 to that in 2008?
Your answer should be compact. 0.47. What is the ratio of the Taxes (in $) in Malaysia in 2005 to that in 2008?
Ensure brevity in your answer.  0.71. What is the ratio of the Taxes (in $) of Slovenia in 2005 to that in 2008?
Your response must be concise. 0.79. What is the ratio of the Taxes (in $) of South Africa in 2005 to that in 2008?
Give a very brief answer. 0.66. What is the ratio of the Taxes (in $) of Liberia in 2005 to that in 2010?
Offer a terse response. 0.41. What is the ratio of the Taxes (in $) of Malaysia in 2005 to that in 2010?
Provide a succinct answer. 0.74. What is the ratio of the Taxes (in $) in Slovenia in 2005 to that in 2010?
Give a very brief answer. 0.97. What is the ratio of the Taxes (in $) in South Africa in 2005 to that in 2010?
Provide a succinct answer. 0.61. What is the ratio of the Taxes (in $) of Liberia in 2005 to that in 2011?
Your response must be concise. 0.34. What is the ratio of the Taxes (in $) in Malaysia in 2005 to that in 2011?
Your response must be concise. 0.6. What is the ratio of the Taxes (in $) of Slovenia in 2005 to that in 2011?
Make the answer very short. 0.92. What is the ratio of the Taxes (in $) in South Africa in 2005 to that in 2011?
Provide a short and direct response. 0.55. What is the ratio of the Taxes (in $) in Liberia in 2005 to that in 2012?
Offer a terse response. 0.26. What is the ratio of the Taxes (in $) in Malaysia in 2005 to that in 2012?
Make the answer very short. 0.53. What is the ratio of the Taxes (in $) in Slovenia in 2005 to that in 2012?
Keep it short and to the point. 0.93. What is the ratio of the Taxes (in $) of South Africa in 2005 to that in 2012?
Your answer should be compact. 0.51. What is the ratio of the Taxes (in $) of Liberia in 2006 to that in 2007?
Your response must be concise. 0.61. What is the ratio of the Taxes (in $) of Malaysia in 2006 to that in 2007?
Offer a terse response. 0.91. What is the ratio of the Taxes (in $) in Slovenia in 2006 to that in 2007?
Offer a terse response. 0.96. What is the ratio of the Taxes (in $) of South Africa in 2006 to that in 2007?
Offer a very short reply. 0.86. What is the ratio of the Taxes (in $) of Liberia in 2006 to that in 2008?
Your answer should be compact. 0.52. What is the ratio of the Taxes (in $) of Malaysia in 2006 to that in 2008?
Your response must be concise. 0.77. What is the ratio of the Taxes (in $) of Slovenia in 2006 to that in 2008?
Provide a short and direct response. 0.88. What is the ratio of the Taxes (in $) of South Africa in 2006 to that in 2008?
Your response must be concise. 0.79. What is the ratio of the Taxes (in $) in Liberia in 2006 to that in 2010?
Make the answer very short. 0.45. What is the ratio of the Taxes (in $) in Malaysia in 2006 to that in 2010?
Your response must be concise. 0.79. What is the ratio of the Taxes (in $) of Slovenia in 2006 to that in 2010?
Ensure brevity in your answer.  1.07. What is the ratio of the Taxes (in $) in South Africa in 2006 to that in 2010?
Your answer should be very brief. 0.73. What is the ratio of the Taxes (in $) of Liberia in 2006 to that in 2011?
Provide a succinct answer. 0.38. What is the ratio of the Taxes (in $) of Malaysia in 2006 to that in 2011?
Ensure brevity in your answer.  0.64. What is the ratio of the Taxes (in $) in Slovenia in 2006 to that in 2011?
Provide a short and direct response. 1.02. What is the ratio of the Taxes (in $) in South Africa in 2006 to that in 2011?
Offer a very short reply. 0.66. What is the ratio of the Taxes (in $) of Liberia in 2006 to that in 2012?
Offer a very short reply. 0.28. What is the ratio of the Taxes (in $) in Malaysia in 2006 to that in 2012?
Offer a very short reply. 0.57. What is the ratio of the Taxes (in $) of Slovenia in 2006 to that in 2012?
Provide a succinct answer. 1.03. What is the ratio of the Taxes (in $) in South Africa in 2006 to that in 2012?
Offer a terse response. 0.6. What is the ratio of the Taxes (in $) of Liberia in 2007 to that in 2008?
Offer a terse response. 0.85. What is the ratio of the Taxes (in $) in Malaysia in 2007 to that in 2008?
Provide a short and direct response. 0.84. What is the ratio of the Taxes (in $) of Slovenia in 2007 to that in 2008?
Keep it short and to the point. 0.91. What is the ratio of the Taxes (in $) in South Africa in 2007 to that in 2008?
Your answer should be very brief. 0.92. What is the ratio of the Taxes (in $) in Liberia in 2007 to that in 2010?
Your answer should be very brief. 0.73. What is the ratio of the Taxes (in $) of Malaysia in 2007 to that in 2010?
Your response must be concise. 0.87. What is the ratio of the Taxes (in $) of Slovenia in 2007 to that in 2010?
Your answer should be very brief. 1.12. What is the ratio of the Taxes (in $) in South Africa in 2007 to that in 2010?
Keep it short and to the point. 0.85. What is the ratio of the Taxes (in $) in Liberia in 2007 to that in 2011?
Offer a very short reply. 0.62. What is the ratio of the Taxes (in $) of Malaysia in 2007 to that in 2011?
Keep it short and to the point. 0.71. What is the ratio of the Taxes (in $) of Slovenia in 2007 to that in 2011?
Offer a very short reply. 1.06. What is the ratio of the Taxes (in $) of South Africa in 2007 to that in 2011?
Provide a succinct answer. 0.76. What is the ratio of the Taxes (in $) of Liberia in 2007 to that in 2012?
Make the answer very short. 0.46. What is the ratio of the Taxes (in $) in Malaysia in 2007 to that in 2012?
Provide a short and direct response. 0.63. What is the ratio of the Taxes (in $) in Slovenia in 2007 to that in 2012?
Provide a short and direct response. 1.08. What is the ratio of the Taxes (in $) of South Africa in 2007 to that in 2012?
Offer a very short reply. 0.7. What is the ratio of the Taxes (in $) of Liberia in 2008 to that in 2010?
Your answer should be very brief. 0.86. What is the ratio of the Taxes (in $) in Malaysia in 2008 to that in 2010?
Ensure brevity in your answer.  1.03. What is the ratio of the Taxes (in $) of Slovenia in 2008 to that in 2010?
Provide a succinct answer. 1.22. What is the ratio of the Taxes (in $) in Liberia in 2008 to that in 2011?
Your response must be concise. 0.73. What is the ratio of the Taxes (in $) of Malaysia in 2008 to that in 2011?
Offer a terse response. 0.84. What is the ratio of the Taxes (in $) in Slovenia in 2008 to that in 2011?
Your answer should be compact. 1.16. What is the ratio of the Taxes (in $) in South Africa in 2008 to that in 2011?
Provide a succinct answer. 0.83. What is the ratio of the Taxes (in $) of Liberia in 2008 to that in 2012?
Provide a succinct answer. 0.55. What is the ratio of the Taxes (in $) of Malaysia in 2008 to that in 2012?
Provide a succinct answer. 0.74. What is the ratio of the Taxes (in $) in Slovenia in 2008 to that in 2012?
Provide a succinct answer. 1.18. What is the ratio of the Taxes (in $) of South Africa in 2008 to that in 2012?
Make the answer very short. 0.76. What is the ratio of the Taxes (in $) of Liberia in 2010 to that in 2011?
Ensure brevity in your answer.  0.85. What is the ratio of the Taxes (in $) of Malaysia in 2010 to that in 2011?
Your response must be concise. 0.81. What is the ratio of the Taxes (in $) in Slovenia in 2010 to that in 2011?
Give a very brief answer. 0.95. What is the ratio of the Taxes (in $) in South Africa in 2010 to that in 2011?
Your answer should be compact. 0.9. What is the ratio of the Taxes (in $) in Liberia in 2010 to that in 2012?
Keep it short and to the point. 0.64. What is the ratio of the Taxes (in $) of Malaysia in 2010 to that in 2012?
Make the answer very short. 0.72. What is the ratio of the Taxes (in $) of Slovenia in 2010 to that in 2012?
Your response must be concise. 0.96. What is the ratio of the Taxes (in $) in South Africa in 2010 to that in 2012?
Give a very brief answer. 0.83. What is the ratio of the Taxes (in $) of Liberia in 2011 to that in 2012?
Your answer should be very brief. 0.75. What is the ratio of the Taxes (in $) of Malaysia in 2011 to that in 2012?
Offer a terse response. 0.89. What is the ratio of the Taxes (in $) of Slovenia in 2011 to that in 2012?
Your answer should be compact. 1.01. What is the ratio of the Taxes (in $) of South Africa in 2011 to that in 2012?
Your response must be concise. 0.92. What is the difference between the highest and the second highest Taxes (in $) in Liberia?
Keep it short and to the point. 1.22e+06. What is the difference between the highest and the second highest Taxes (in $) in Malaysia?
Offer a very short reply. 1.68e+1. What is the difference between the highest and the second highest Taxes (in $) in Slovenia?
Your answer should be compact. 6.39e+08. What is the difference between the highest and the second highest Taxes (in $) of South Africa?
Provide a short and direct response. 7.07e+1. What is the difference between the highest and the lowest Taxes (in $) of Liberia?
Your response must be concise. 3.66e+06. What is the difference between the highest and the lowest Taxes (in $) in Malaysia?
Make the answer very short. 7.10e+1. What is the difference between the highest and the lowest Taxes (in $) in Slovenia?
Keep it short and to the point. 1.53e+09. What is the difference between the highest and the lowest Taxes (in $) in South Africa?
Offer a terse response. 4.10e+11. 